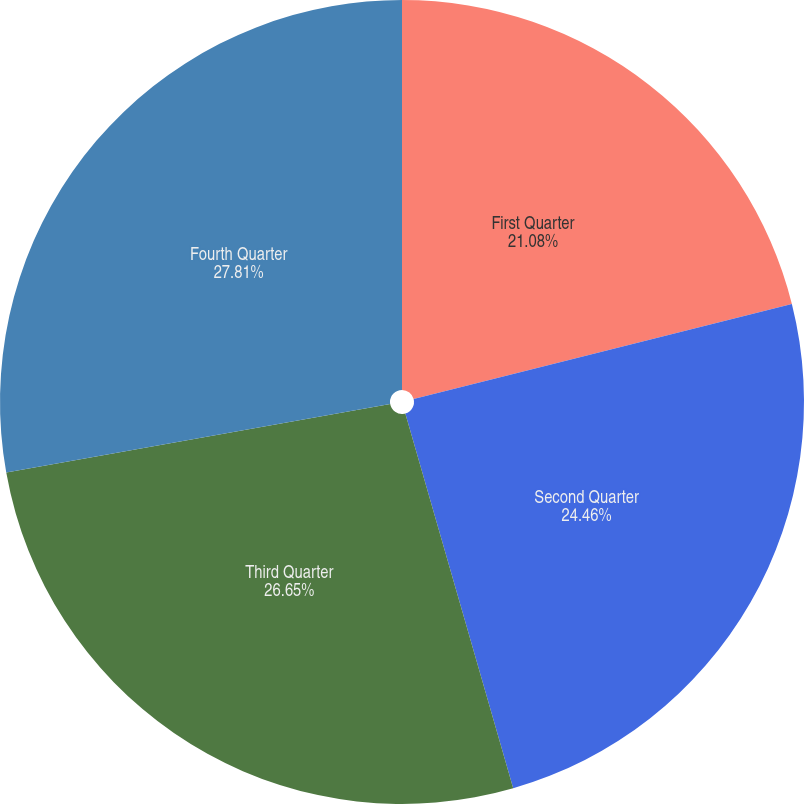Convert chart. <chart><loc_0><loc_0><loc_500><loc_500><pie_chart><fcel>First Quarter<fcel>Second Quarter<fcel>Third Quarter<fcel>Fourth Quarter<nl><fcel>21.08%<fcel>24.46%<fcel>26.65%<fcel>27.81%<nl></chart> 